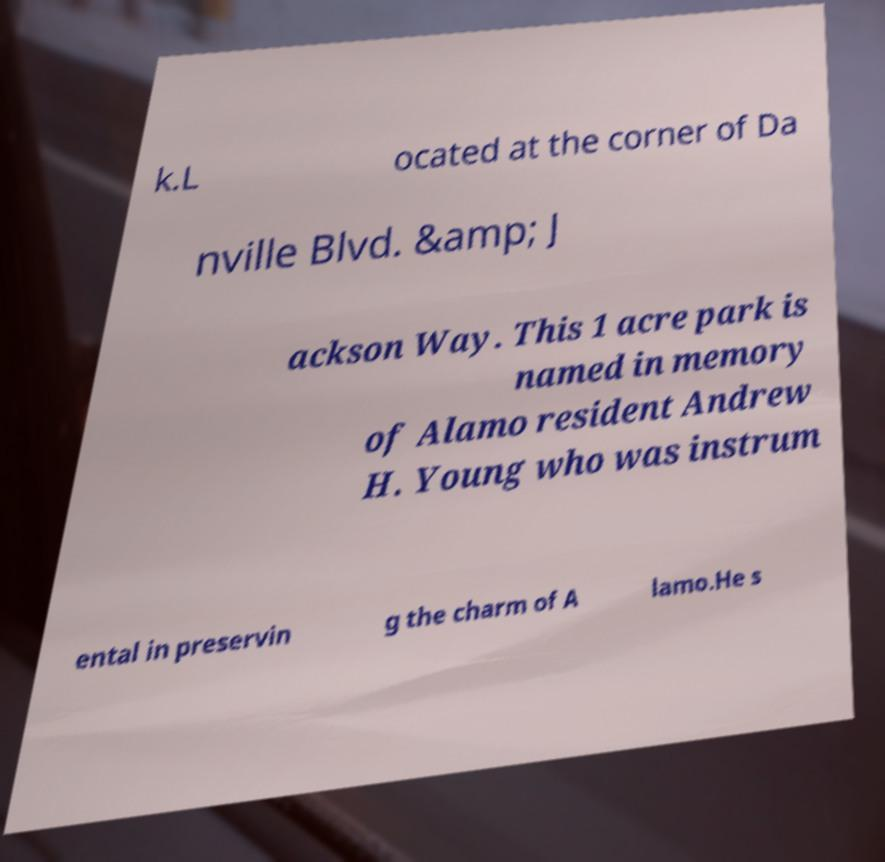Please identify and transcribe the text found in this image. k.L ocated at the corner of Da nville Blvd. &amp; J ackson Way. This 1 acre park is named in memory of Alamo resident Andrew H. Young who was instrum ental in preservin g the charm of A lamo.He s 